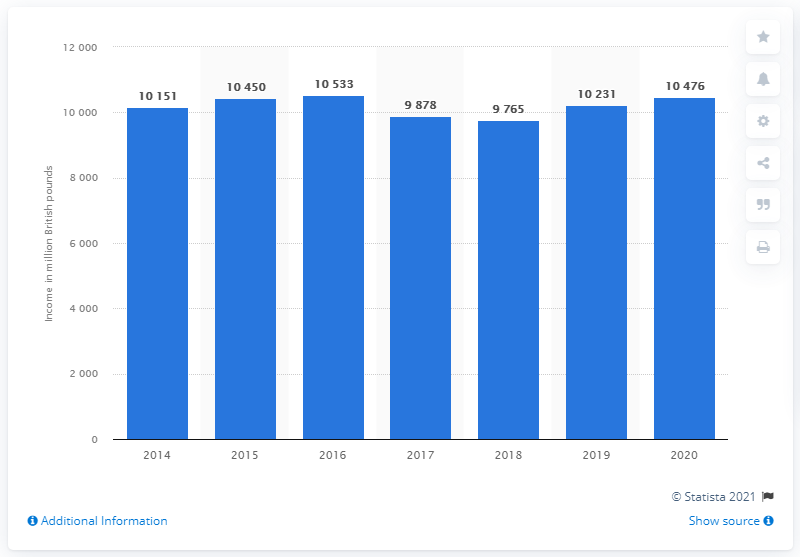Indicate a few pertinent items in this graphic. Barclays International Corporate and Investment Bank reported an income of approximately 10,476 in 2020. 